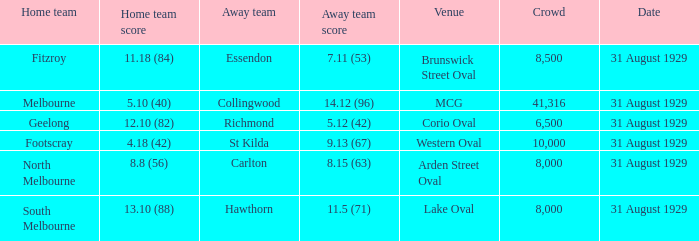What was the away team when the game was at corio oval? Richmond. Could you parse the entire table? {'header': ['Home team', 'Home team score', 'Away team', 'Away team score', 'Venue', 'Crowd', 'Date'], 'rows': [['Fitzroy', '11.18 (84)', 'Essendon', '7.11 (53)', 'Brunswick Street Oval', '8,500', '31 August 1929'], ['Melbourne', '5.10 (40)', 'Collingwood', '14.12 (96)', 'MCG', '41,316', '31 August 1929'], ['Geelong', '12.10 (82)', 'Richmond', '5.12 (42)', 'Corio Oval', '6,500', '31 August 1929'], ['Footscray', '4.18 (42)', 'St Kilda', '9.13 (67)', 'Western Oval', '10,000', '31 August 1929'], ['North Melbourne', '8.8 (56)', 'Carlton', '8.15 (63)', 'Arden Street Oval', '8,000', '31 August 1929'], ['South Melbourne', '13.10 (88)', 'Hawthorn', '11.5 (71)', 'Lake Oval', '8,000', '31 August 1929']]} 